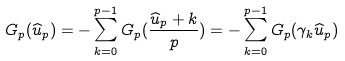Convert formula to latex. <formula><loc_0><loc_0><loc_500><loc_500>G _ { p } ( \widehat { u } _ { p } ) = - \sum _ { k = 0 } ^ { p - 1 } G _ { p } ( \frac { \widehat { u } _ { p } + k } { p } ) = - \sum _ { k = 0 } ^ { p - 1 } G _ { p } ( \gamma _ { k } \widehat { u } _ { p } )</formula> 